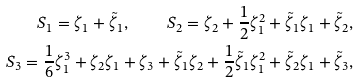<formula> <loc_0><loc_0><loc_500><loc_500>S _ { 1 } = \zeta _ { 1 } + \tilde { \zeta } _ { 1 } , \quad S _ { 2 } = \zeta _ { 2 } + \frac { 1 } { 2 } \zeta _ { 1 } ^ { 2 } + \tilde { \zeta } _ { 1 } \zeta _ { 1 } + \tilde { \zeta } _ { 2 } , \\ S _ { 3 } = \frac { 1 } { 6 } \zeta _ { 1 } ^ { 3 } + \zeta _ { 2 } \zeta _ { 1 } + \zeta _ { 3 } + \tilde { \zeta } _ { 1 } \zeta _ { 2 } + \frac { 1 } { 2 } \tilde { \zeta } _ { 1 } \zeta _ { 1 } ^ { 2 } + \tilde { \zeta } _ { 2 } \zeta _ { 1 } + \tilde { \zeta } _ { 3 } ,</formula> 